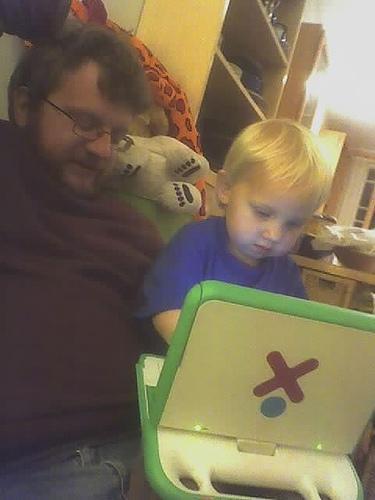How many people are in this photo?
Give a very brief answer. 2. How many people are there?
Give a very brief answer. 2. How many cups are in the picture?
Give a very brief answer. 0. 